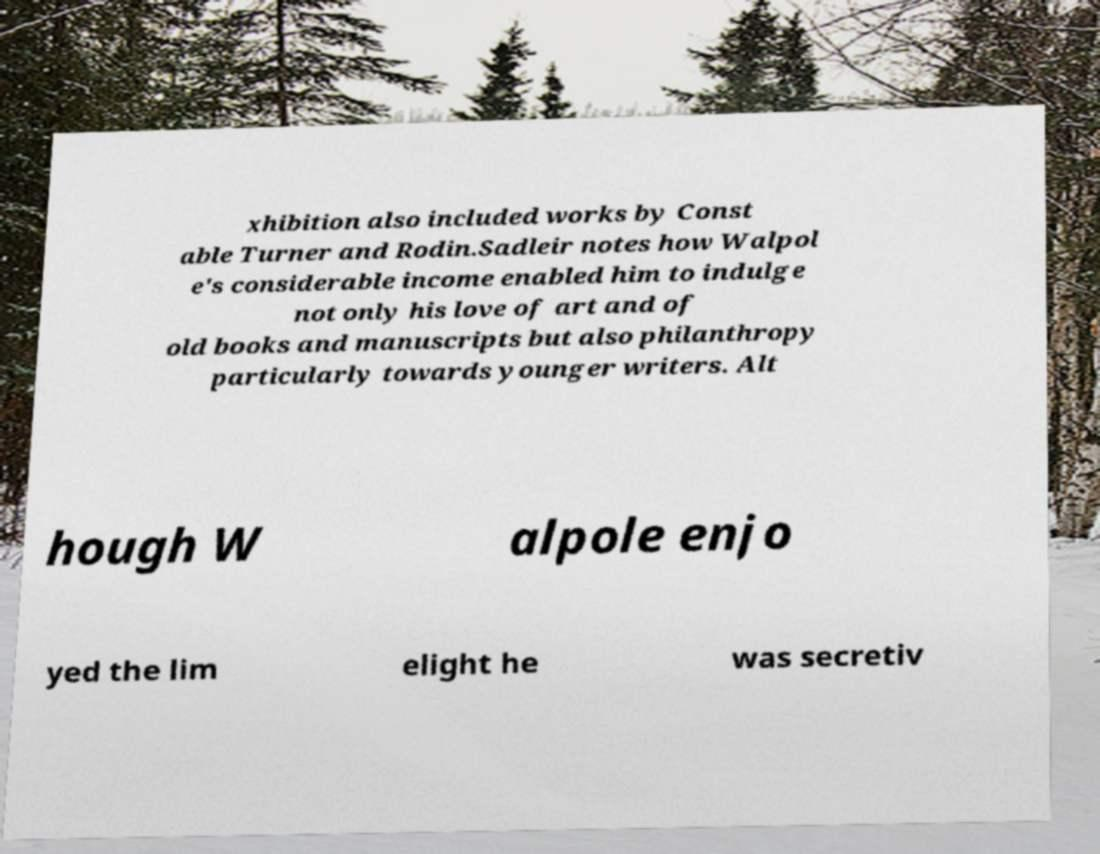I need the written content from this picture converted into text. Can you do that? xhibition also included works by Const able Turner and Rodin.Sadleir notes how Walpol e's considerable income enabled him to indulge not only his love of art and of old books and manuscripts but also philanthropy particularly towards younger writers. Alt hough W alpole enjo yed the lim elight he was secretiv 